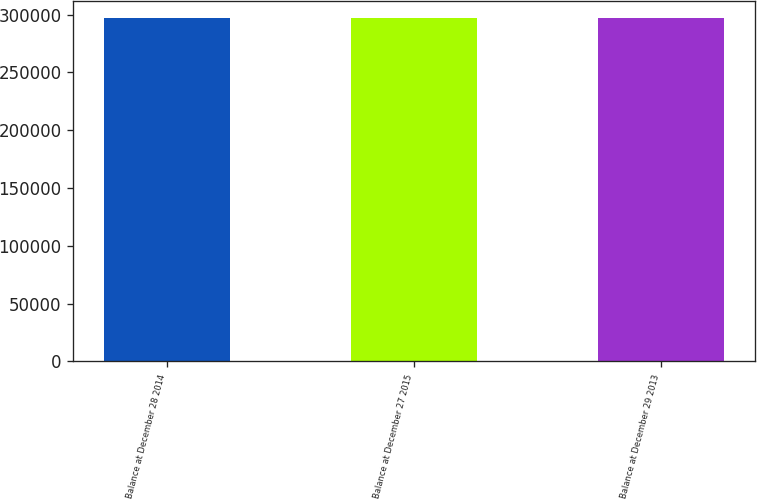Convert chart to OTSL. <chart><loc_0><loc_0><loc_500><loc_500><bar_chart><fcel>Balance at December 28 2014<fcel>Balance at December 27 2015<fcel>Balance at December 29 2013<nl><fcel>296978<fcel>296978<fcel>296978<nl></chart> 